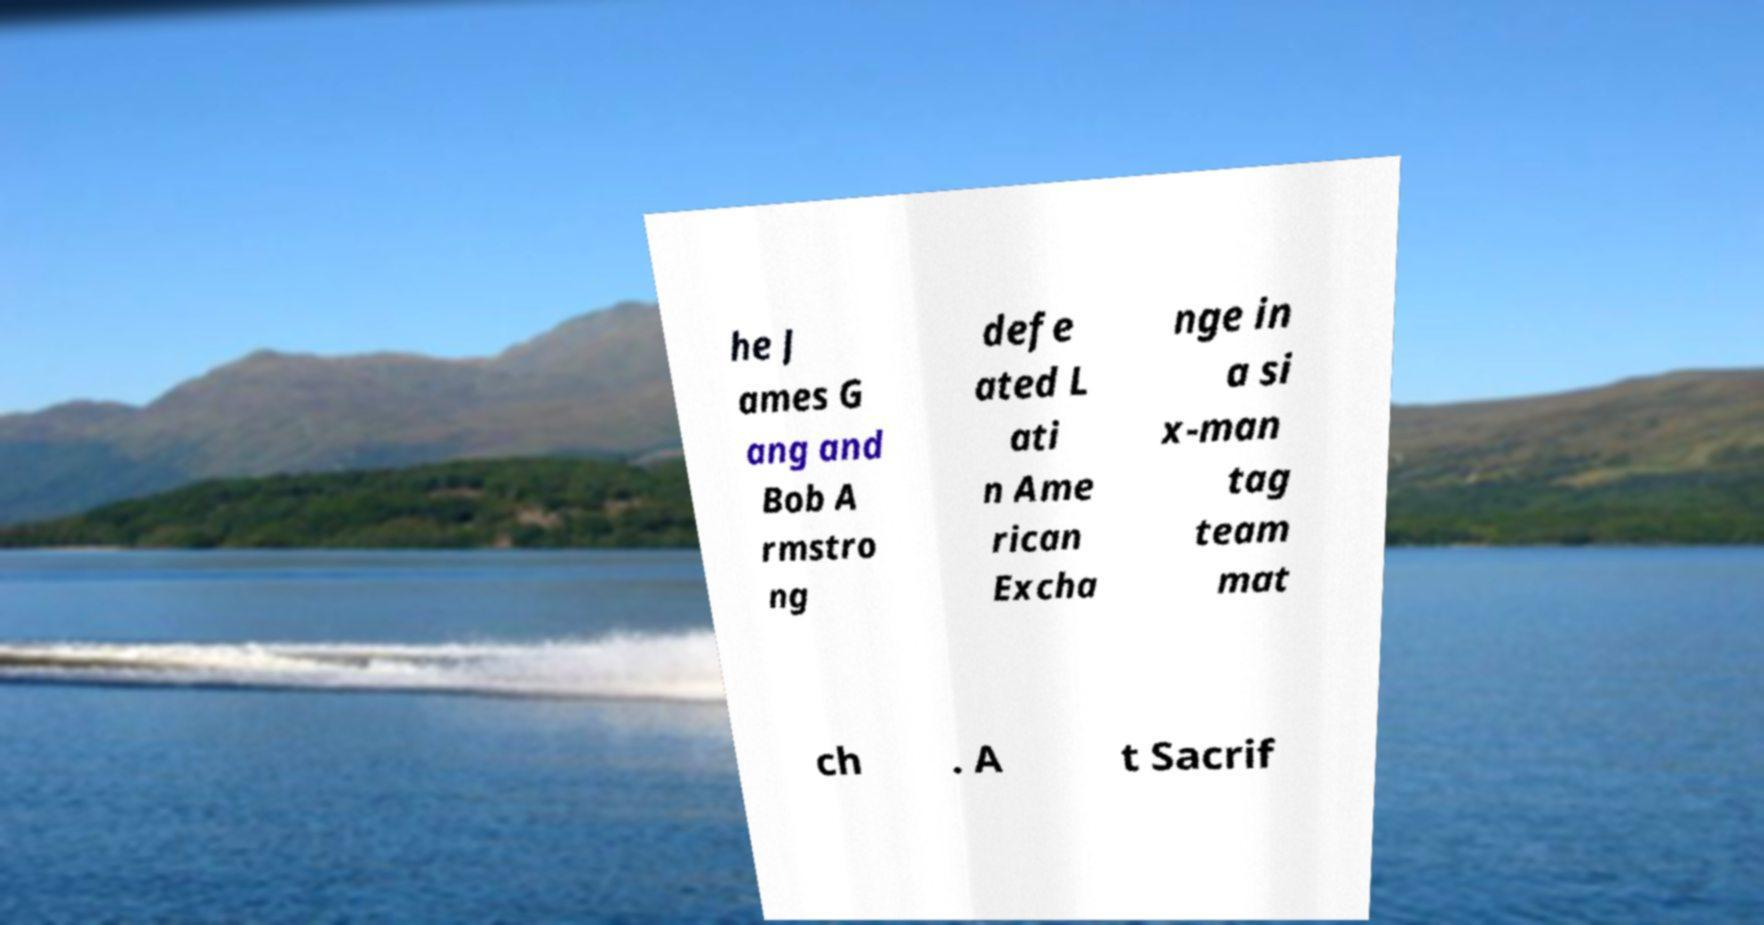What messages or text are displayed in this image? I need them in a readable, typed format. he J ames G ang and Bob A rmstro ng defe ated L ati n Ame rican Excha nge in a si x-man tag team mat ch . A t Sacrif 